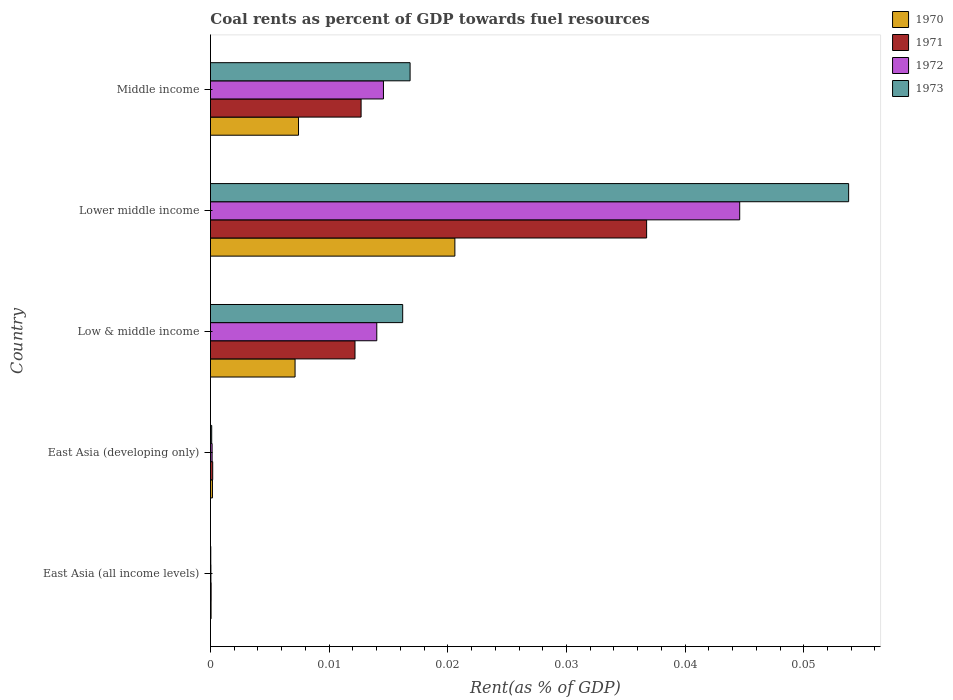How many different coloured bars are there?
Your answer should be compact. 4. How many groups of bars are there?
Offer a very short reply. 5. How many bars are there on the 3rd tick from the top?
Ensure brevity in your answer.  4. How many bars are there on the 3rd tick from the bottom?
Offer a very short reply. 4. What is the label of the 2nd group of bars from the top?
Give a very brief answer. Lower middle income. In how many cases, is the number of bars for a given country not equal to the number of legend labels?
Provide a short and direct response. 0. What is the coal rent in 1972 in Middle income?
Give a very brief answer. 0.01. Across all countries, what is the maximum coal rent in 1973?
Make the answer very short. 0.05. Across all countries, what is the minimum coal rent in 1972?
Offer a very short reply. 3.67730514806032e-5. In which country was the coal rent in 1970 maximum?
Give a very brief answer. Lower middle income. In which country was the coal rent in 1972 minimum?
Your answer should be compact. East Asia (all income levels). What is the total coal rent in 1970 in the graph?
Give a very brief answer. 0.04. What is the difference between the coal rent in 1970 in East Asia (all income levels) and that in Lower middle income?
Ensure brevity in your answer.  -0.02. What is the difference between the coal rent in 1973 in Middle income and the coal rent in 1972 in East Asia (all income levels)?
Your answer should be very brief. 0.02. What is the average coal rent in 1971 per country?
Provide a succinct answer. 0.01. What is the difference between the coal rent in 1973 and coal rent in 1971 in Low & middle income?
Your answer should be compact. 0. What is the ratio of the coal rent in 1971 in Lower middle income to that in Middle income?
Keep it short and to the point. 2.9. What is the difference between the highest and the second highest coal rent in 1971?
Provide a short and direct response. 0.02. What is the difference between the highest and the lowest coal rent in 1971?
Provide a short and direct response. 0.04. In how many countries, is the coal rent in 1970 greater than the average coal rent in 1970 taken over all countries?
Keep it short and to the point. 3. What does the 2nd bar from the bottom in Low & middle income represents?
Make the answer very short. 1971. Are all the bars in the graph horizontal?
Offer a very short reply. Yes. How many countries are there in the graph?
Provide a succinct answer. 5. Does the graph contain any zero values?
Offer a very short reply. No. Where does the legend appear in the graph?
Provide a short and direct response. Top right. How many legend labels are there?
Make the answer very short. 4. What is the title of the graph?
Your answer should be very brief. Coal rents as percent of GDP towards fuel resources. Does "1965" appear as one of the legend labels in the graph?
Ensure brevity in your answer.  No. What is the label or title of the X-axis?
Offer a terse response. Rent(as % of GDP). What is the label or title of the Y-axis?
Provide a short and direct response. Country. What is the Rent(as % of GDP) in 1970 in East Asia (all income levels)?
Provide a short and direct response. 5.1314079013758e-5. What is the Rent(as % of GDP) in 1971 in East Asia (all income levels)?
Ensure brevity in your answer.  5.470114168356261e-5. What is the Rent(as % of GDP) in 1972 in East Asia (all income levels)?
Offer a very short reply. 3.67730514806032e-5. What is the Rent(as % of GDP) of 1973 in East Asia (all income levels)?
Your answer should be very brief. 2.64171247686014e-5. What is the Rent(as % of GDP) in 1970 in East Asia (developing only)?
Give a very brief answer. 0. What is the Rent(as % of GDP) in 1971 in East Asia (developing only)?
Make the answer very short. 0. What is the Rent(as % of GDP) in 1972 in East Asia (developing only)?
Provide a short and direct response. 0. What is the Rent(as % of GDP) in 1973 in East Asia (developing only)?
Keep it short and to the point. 0. What is the Rent(as % of GDP) of 1970 in Low & middle income?
Keep it short and to the point. 0.01. What is the Rent(as % of GDP) in 1971 in Low & middle income?
Your answer should be compact. 0.01. What is the Rent(as % of GDP) of 1972 in Low & middle income?
Give a very brief answer. 0.01. What is the Rent(as % of GDP) in 1973 in Low & middle income?
Make the answer very short. 0.02. What is the Rent(as % of GDP) of 1970 in Lower middle income?
Your answer should be compact. 0.02. What is the Rent(as % of GDP) in 1971 in Lower middle income?
Make the answer very short. 0.04. What is the Rent(as % of GDP) in 1972 in Lower middle income?
Make the answer very short. 0.04. What is the Rent(as % of GDP) of 1973 in Lower middle income?
Keep it short and to the point. 0.05. What is the Rent(as % of GDP) in 1970 in Middle income?
Ensure brevity in your answer.  0.01. What is the Rent(as % of GDP) in 1971 in Middle income?
Your answer should be compact. 0.01. What is the Rent(as % of GDP) in 1972 in Middle income?
Your answer should be very brief. 0.01. What is the Rent(as % of GDP) in 1973 in Middle income?
Offer a very short reply. 0.02. Across all countries, what is the maximum Rent(as % of GDP) of 1970?
Ensure brevity in your answer.  0.02. Across all countries, what is the maximum Rent(as % of GDP) in 1971?
Provide a short and direct response. 0.04. Across all countries, what is the maximum Rent(as % of GDP) in 1972?
Ensure brevity in your answer.  0.04. Across all countries, what is the maximum Rent(as % of GDP) in 1973?
Your answer should be very brief. 0.05. Across all countries, what is the minimum Rent(as % of GDP) of 1970?
Offer a terse response. 5.1314079013758e-5. Across all countries, what is the minimum Rent(as % of GDP) in 1971?
Keep it short and to the point. 5.470114168356261e-5. Across all countries, what is the minimum Rent(as % of GDP) in 1972?
Your answer should be very brief. 3.67730514806032e-5. Across all countries, what is the minimum Rent(as % of GDP) in 1973?
Offer a terse response. 2.64171247686014e-5. What is the total Rent(as % of GDP) of 1970 in the graph?
Give a very brief answer. 0.04. What is the total Rent(as % of GDP) of 1971 in the graph?
Make the answer very short. 0.06. What is the total Rent(as % of GDP) in 1972 in the graph?
Offer a very short reply. 0.07. What is the total Rent(as % of GDP) in 1973 in the graph?
Make the answer very short. 0.09. What is the difference between the Rent(as % of GDP) of 1970 in East Asia (all income levels) and that in East Asia (developing only)?
Provide a short and direct response. -0. What is the difference between the Rent(as % of GDP) of 1971 in East Asia (all income levels) and that in East Asia (developing only)?
Offer a very short reply. -0. What is the difference between the Rent(as % of GDP) in 1972 in East Asia (all income levels) and that in East Asia (developing only)?
Offer a terse response. -0. What is the difference between the Rent(as % of GDP) in 1973 in East Asia (all income levels) and that in East Asia (developing only)?
Offer a very short reply. -0. What is the difference between the Rent(as % of GDP) in 1970 in East Asia (all income levels) and that in Low & middle income?
Make the answer very short. -0.01. What is the difference between the Rent(as % of GDP) in 1971 in East Asia (all income levels) and that in Low & middle income?
Your answer should be compact. -0.01. What is the difference between the Rent(as % of GDP) of 1972 in East Asia (all income levels) and that in Low & middle income?
Keep it short and to the point. -0.01. What is the difference between the Rent(as % of GDP) in 1973 in East Asia (all income levels) and that in Low & middle income?
Provide a short and direct response. -0.02. What is the difference between the Rent(as % of GDP) of 1970 in East Asia (all income levels) and that in Lower middle income?
Your response must be concise. -0.02. What is the difference between the Rent(as % of GDP) of 1971 in East Asia (all income levels) and that in Lower middle income?
Make the answer very short. -0.04. What is the difference between the Rent(as % of GDP) of 1972 in East Asia (all income levels) and that in Lower middle income?
Keep it short and to the point. -0.04. What is the difference between the Rent(as % of GDP) in 1973 in East Asia (all income levels) and that in Lower middle income?
Provide a succinct answer. -0.05. What is the difference between the Rent(as % of GDP) of 1970 in East Asia (all income levels) and that in Middle income?
Offer a terse response. -0.01. What is the difference between the Rent(as % of GDP) of 1971 in East Asia (all income levels) and that in Middle income?
Your answer should be very brief. -0.01. What is the difference between the Rent(as % of GDP) in 1972 in East Asia (all income levels) and that in Middle income?
Your response must be concise. -0.01. What is the difference between the Rent(as % of GDP) in 1973 in East Asia (all income levels) and that in Middle income?
Make the answer very short. -0.02. What is the difference between the Rent(as % of GDP) in 1970 in East Asia (developing only) and that in Low & middle income?
Offer a very short reply. -0.01. What is the difference between the Rent(as % of GDP) of 1971 in East Asia (developing only) and that in Low & middle income?
Ensure brevity in your answer.  -0.01. What is the difference between the Rent(as % of GDP) in 1972 in East Asia (developing only) and that in Low & middle income?
Make the answer very short. -0.01. What is the difference between the Rent(as % of GDP) of 1973 in East Asia (developing only) and that in Low & middle income?
Your response must be concise. -0.02. What is the difference between the Rent(as % of GDP) in 1970 in East Asia (developing only) and that in Lower middle income?
Offer a terse response. -0.02. What is the difference between the Rent(as % of GDP) of 1971 in East Asia (developing only) and that in Lower middle income?
Ensure brevity in your answer.  -0.04. What is the difference between the Rent(as % of GDP) in 1972 in East Asia (developing only) and that in Lower middle income?
Offer a very short reply. -0.04. What is the difference between the Rent(as % of GDP) in 1973 in East Asia (developing only) and that in Lower middle income?
Ensure brevity in your answer.  -0.05. What is the difference between the Rent(as % of GDP) of 1970 in East Asia (developing only) and that in Middle income?
Give a very brief answer. -0.01. What is the difference between the Rent(as % of GDP) of 1971 in East Asia (developing only) and that in Middle income?
Offer a terse response. -0.01. What is the difference between the Rent(as % of GDP) in 1972 in East Asia (developing only) and that in Middle income?
Provide a short and direct response. -0.01. What is the difference between the Rent(as % of GDP) in 1973 in East Asia (developing only) and that in Middle income?
Your answer should be very brief. -0.02. What is the difference between the Rent(as % of GDP) in 1970 in Low & middle income and that in Lower middle income?
Keep it short and to the point. -0.01. What is the difference between the Rent(as % of GDP) in 1971 in Low & middle income and that in Lower middle income?
Keep it short and to the point. -0.02. What is the difference between the Rent(as % of GDP) in 1972 in Low & middle income and that in Lower middle income?
Ensure brevity in your answer.  -0.03. What is the difference between the Rent(as % of GDP) of 1973 in Low & middle income and that in Lower middle income?
Give a very brief answer. -0.04. What is the difference between the Rent(as % of GDP) in 1970 in Low & middle income and that in Middle income?
Provide a short and direct response. -0. What is the difference between the Rent(as % of GDP) of 1971 in Low & middle income and that in Middle income?
Your answer should be compact. -0. What is the difference between the Rent(as % of GDP) in 1972 in Low & middle income and that in Middle income?
Your response must be concise. -0. What is the difference between the Rent(as % of GDP) in 1973 in Low & middle income and that in Middle income?
Give a very brief answer. -0. What is the difference between the Rent(as % of GDP) of 1970 in Lower middle income and that in Middle income?
Provide a short and direct response. 0.01. What is the difference between the Rent(as % of GDP) of 1971 in Lower middle income and that in Middle income?
Ensure brevity in your answer.  0.02. What is the difference between the Rent(as % of GDP) in 1973 in Lower middle income and that in Middle income?
Provide a succinct answer. 0.04. What is the difference between the Rent(as % of GDP) of 1970 in East Asia (all income levels) and the Rent(as % of GDP) of 1971 in East Asia (developing only)?
Your answer should be compact. -0. What is the difference between the Rent(as % of GDP) in 1970 in East Asia (all income levels) and the Rent(as % of GDP) in 1972 in East Asia (developing only)?
Your response must be concise. -0. What is the difference between the Rent(as % of GDP) in 1970 in East Asia (all income levels) and the Rent(as % of GDP) in 1973 in East Asia (developing only)?
Make the answer very short. -0. What is the difference between the Rent(as % of GDP) in 1971 in East Asia (all income levels) and the Rent(as % of GDP) in 1972 in East Asia (developing only)?
Provide a short and direct response. -0. What is the difference between the Rent(as % of GDP) in 1972 in East Asia (all income levels) and the Rent(as % of GDP) in 1973 in East Asia (developing only)?
Offer a very short reply. -0. What is the difference between the Rent(as % of GDP) of 1970 in East Asia (all income levels) and the Rent(as % of GDP) of 1971 in Low & middle income?
Give a very brief answer. -0.01. What is the difference between the Rent(as % of GDP) in 1970 in East Asia (all income levels) and the Rent(as % of GDP) in 1972 in Low & middle income?
Ensure brevity in your answer.  -0.01. What is the difference between the Rent(as % of GDP) of 1970 in East Asia (all income levels) and the Rent(as % of GDP) of 1973 in Low & middle income?
Make the answer very short. -0.02. What is the difference between the Rent(as % of GDP) of 1971 in East Asia (all income levels) and the Rent(as % of GDP) of 1972 in Low & middle income?
Your answer should be compact. -0.01. What is the difference between the Rent(as % of GDP) of 1971 in East Asia (all income levels) and the Rent(as % of GDP) of 1973 in Low & middle income?
Your response must be concise. -0.02. What is the difference between the Rent(as % of GDP) of 1972 in East Asia (all income levels) and the Rent(as % of GDP) of 1973 in Low & middle income?
Keep it short and to the point. -0.02. What is the difference between the Rent(as % of GDP) in 1970 in East Asia (all income levels) and the Rent(as % of GDP) in 1971 in Lower middle income?
Ensure brevity in your answer.  -0.04. What is the difference between the Rent(as % of GDP) in 1970 in East Asia (all income levels) and the Rent(as % of GDP) in 1972 in Lower middle income?
Offer a very short reply. -0.04. What is the difference between the Rent(as % of GDP) of 1970 in East Asia (all income levels) and the Rent(as % of GDP) of 1973 in Lower middle income?
Your response must be concise. -0.05. What is the difference between the Rent(as % of GDP) in 1971 in East Asia (all income levels) and the Rent(as % of GDP) in 1972 in Lower middle income?
Offer a very short reply. -0.04. What is the difference between the Rent(as % of GDP) of 1971 in East Asia (all income levels) and the Rent(as % of GDP) of 1973 in Lower middle income?
Provide a short and direct response. -0.05. What is the difference between the Rent(as % of GDP) in 1972 in East Asia (all income levels) and the Rent(as % of GDP) in 1973 in Lower middle income?
Your answer should be compact. -0.05. What is the difference between the Rent(as % of GDP) of 1970 in East Asia (all income levels) and the Rent(as % of GDP) of 1971 in Middle income?
Your answer should be compact. -0.01. What is the difference between the Rent(as % of GDP) in 1970 in East Asia (all income levels) and the Rent(as % of GDP) in 1972 in Middle income?
Provide a succinct answer. -0.01. What is the difference between the Rent(as % of GDP) in 1970 in East Asia (all income levels) and the Rent(as % of GDP) in 1973 in Middle income?
Offer a terse response. -0.02. What is the difference between the Rent(as % of GDP) of 1971 in East Asia (all income levels) and the Rent(as % of GDP) of 1972 in Middle income?
Ensure brevity in your answer.  -0.01. What is the difference between the Rent(as % of GDP) of 1971 in East Asia (all income levels) and the Rent(as % of GDP) of 1973 in Middle income?
Keep it short and to the point. -0.02. What is the difference between the Rent(as % of GDP) in 1972 in East Asia (all income levels) and the Rent(as % of GDP) in 1973 in Middle income?
Provide a succinct answer. -0.02. What is the difference between the Rent(as % of GDP) of 1970 in East Asia (developing only) and the Rent(as % of GDP) of 1971 in Low & middle income?
Provide a short and direct response. -0.01. What is the difference between the Rent(as % of GDP) in 1970 in East Asia (developing only) and the Rent(as % of GDP) in 1972 in Low & middle income?
Offer a terse response. -0.01. What is the difference between the Rent(as % of GDP) of 1970 in East Asia (developing only) and the Rent(as % of GDP) of 1973 in Low & middle income?
Offer a terse response. -0.02. What is the difference between the Rent(as % of GDP) of 1971 in East Asia (developing only) and the Rent(as % of GDP) of 1972 in Low & middle income?
Your answer should be very brief. -0.01. What is the difference between the Rent(as % of GDP) of 1971 in East Asia (developing only) and the Rent(as % of GDP) of 1973 in Low & middle income?
Give a very brief answer. -0.02. What is the difference between the Rent(as % of GDP) of 1972 in East Asia (developing only) and the Rent(as % of GDP) of 1973 in Low & middle income?
Keep it short and to the point. -0.02. What is the difference between the Rent(as % of GDP) in 1970 in East Asia (developing only) and the Rent(as % of GDP) in 1971 in Lower middle income?
Make the answer very short. -0.04. What is the difference between the Rent(as % of GDP) in 1970 in East Asia (developing only) and the Rent(as % of GDP) in 1972 in Lower middle income?
Give a very brief answer. -0.04. What is the difference between the Rent(as % of GDP) in 1970 in East Asia (developing only) and the Rent(as % of GDP) in 1973 in Lower middle income?
Ensure brevity in your answer.  -0.05. What is the difference between the Rent(as % of GDP) of 1971 in East Asia (developing only) and the Rent(as % of GDP) of 1972 in Lower middle income?
Your response must be concise. -0.04. What is the difference between the Rent(as % of GDP) in 1971 in East Asia (developing only) and the Rent(as % of GDP) in 1973 in Lower middle income?
Offer a very short reply. -0.05. What is the difference between the Rent(as % of GDP) in 1972 in East Asia (developing only) and the Rent(as % of GDP) in 1973 in Lower middle income?
Your response must be concise. -0.05. What is the difference between the Rent(as % of GDP) in 1970 in East Asia (developing only) and the Rent(as % of GDP) in 1971 in Middle income?
Keep it short and to the point. -0.01. What is the difference between the Rent(as % of GDP) of 1970 in East Asia (developing only) and the Rent(as % of GDP) of 1972 in Middle income?
Your answer should be compact. -0.01. What is the difference between the Rent(as % of GDP) of 1970 in East Asia (developing only) and the Rent(as % of GDP) of 1973 in Middle income?
Offer a terse response. -0.02. What is the difference between the Rent(as % of GDP) in 1971 in East Asia (developing only) and the Rent(as % of GDP) in 1972 in Middle income?
Your answer should be compact. -0.01. What is the difference between the Rent(as % of GDP) of 1971 in East Asia (developing only) and the Rent(as % of GDP) of 1973 in Middle income?
Your answer should be very brief. -0.02. What is the difference between the Rent(as % of GDP) in 1972 in East Asia (developing only) and the Rent(as % of GDP) in 1973 in Middle income?
Ensure brevity in your answer.  -0.02. What is the difference between the Rent(as % of GDP) of 1970 in Low & middle income and the Rent(as % of GDP) of 1971 in Lower middle income?
Provide a succinct answer. -0.03. What is the difference between the Rent(as % of GDP) of 1970 in Low & middle income and the Rent(as % of GDP) of 1972 in Lower middle income?
Ensure brevity in your answer.  -0.04. What is the difference between the Rent(as % of GDP) in 1970 in Low & middle income and the Rent(as % of GDP) in 1973 in Lower middle income?
Offer a terse response. -0.05. What is the difference between the Rent(as % of GDP) in 1971 in Low & middle income and the Rent(as % of GDP) in 1972 in Lower middle income?
Ensure brevity in your answer.  -0.03. What is the difference between the Rent(as % of GDP) in 1971 in Low & middle income and the Rent(as % of GDP) in 1973 in Lower middle income?
Make the answer very short. -0.04. What is the difference between the Rent(as % of GDP) of 1972 in Low & middle income and the Rent(as % of GDP) of 1973 in Lower middle income?
Provide a succinct answer. -0.04. What is the difference between the Rent(as % of GDP) of 1970 in Low & middle income and the Rent(as % of GDP) of 1971 in Middle income?
Give a very brief answer. -0.01. What is the difference between the Rent(as % of GDP) in 1970 in Low & middle income and the Rent(as % of GDP) in 1972 in Middle income?
Offer a terse response. -0.01. What is the difference between the Rent(as % of GDP) of 1970 in Low & middle income and the Rent(as % of GDP) of 1973 in Middle income?
Keep it short and to the point. -0.01. What is the difference between the Rent(as % of GDP) in 1971 in Low & middle income and the Rent(as % of GDP) in 1972 in Middle income?
Offer a terse response. -0. What is the difference between the Rent(as % of GDP) of 1971 in Low & middle income and the Rent(as % of GDP) of 1973 in Middle income?
Provide a short and direct response. -0. What is the difference between the Rent(as % of GDP) of 1972 in Low & middle income and the Rent(as % of GDP) of 1973 in Middle income?
Ensure brevity in your answer.  -0. What is the difference between the Rent(as % of GDP) in 1970 in Lower middle income and the Rent(as % of GDP) in 1971 in Middle income?
Your response must be concise. 0.01. What is the difference between the Rent(as % of GDP) in 1970 in Lower middle income and the Rent(as % of GDP) in 1972 in Middle income?
Offer a very short reply. 0.01. What is the difference between the Rent(as % of GDP) of 1970 in Lower middle income and the Rent(as % of GDP) of 1973 in Middle income?
Provide a short and direct response. 0. What is the difference between the Rent(as % of GDP) of 1971 in Lower middle income and the Rent(as % of GDP) of 1972 in Middle income?
Your answer should be very brief. 0.02. What is the difference between the Rent(as % of GDP) of 1971 in Lower middle income and the Rent(as % of GDP) of 1973 in Middle income?
Your response must be concise. 0.02. What is the difference between the Rent(as % of GDP) in 1972 in Lower middle income and the Rent(as % of GDP) in 1973 in Middle income?
Offer a terse response. 0.03. What is the average Rent(as % of GDP) of 1970 per country?
Keep it short and to the point. 0.01. What is the average Rent(as % of GDP) of 1971 per country?
Provide a succinct answer. 0.01. What is the average Rent(as % of GDP) in 1972 per country?
Provide a short and direct response. 0.01. What is the average Rent(as % of GDP) of 1973 per country?
Provide a short and direct response. 0.02. What is the difference between the Rent(as % of GDP) in 1970 and Rent(as % of GDP) in 1971 in East Asia (all income levels)?
Make the answer very short. -0. What is the difference between the Rent(as % of GDP) of 1970 and Rent(as % of GDP) of 1973 in East Asia (all income levels)?
Offer a terse response. 0. What is the difference between the Rent(as % of GDP) in 1971 and Rent(as % of GDP) in 1973 in East Asia (all income levels)?
Offer a terse response. 0. What is the difference between the Rent(as % of GDP) in 1972 and Rent(as % of GDP) in 1973 in East Asia (all income levels)?
Offer a very short reply. 0. What is the difference between the Rent(as % of GDP) in 1970 and Rent(as % of GDP) in 1972 in East Asia (developing only)?
Your answer should be very brief. 0. What is the difference between the Rent(as % of GDP) of 1971 and Rent(as % of GDP) of 1973 in East Asia (developing only)?
Offer a very short reply. 0. What is the difference between the Rent(as % of GDP) of 1972 and Rent(as % of GDP) of 1973 in East Asia (developing only)?
Keep it short and to the point. 0. What is the difference between the Rent(as % of GDP) of 1970 and Rent(as % of GDP) of 1971 in Low & middle income?
Ensure brevity in your answer.  -0.01. What is the difference between the Rent(as % of GDP) in 1970 and Rent(as % of GDP) in 1972 in Low & middle income?
Provide a succinct answer. -0.01. What is the difference between the Rent(as % of GDP) in 1970 and Rent(as % of GDP) in 1973 in Low & middle income?
Give a very brief answer. -0.01. What is the difference between the Rent(as % of GDP) of 1971 and Rent(as % of GDP) of 1972 in Low & middle income?
Ensure brevity in your answer.  -0. What is the difference between the Rent(as % of GDP) of 1971 and Rent(as % of GDP) of 1973 in Low & middle income?
Your answer should be very brief. -0. What is the difference between the Rent(as % of GDP) in 1972 and Rent(as % of GDP) in 1973 in Low & middle income?
Provide a short and direct response. -0. What is the difference between the Rent(as % of GDP) of 1970 and Rent(as % of GDP) of 1971 in Lower middle income?
Your answer should be very brief. -0.02. What is the difference between the Rent(as % of GDP) in 1970 and Rent(as % of GDP) in 1972 in Lower middle income?
Offer a terse response. -0.02. What is the difference between the Rent(as % of GDP) in 1970 and Rent(as % of GDP) in 1973 in Lower middle income?
Give a very brief answer. -0.03. What is the difference between the Rent(as % of GDP) in 1971 and Rent(as % of GDP) in 1972 in Lower middle income?
Provide a short and direct response. -0.01. What is the difference between the Rent(as % of GDP) of 1971 and Rent(as % of GDP) of 1973 in Lower middle income?
Keep it short and to the point. -0.02. What is the difference between the Rent(as % of GDP) in 1972 and Rent(as % of GDP) in 1973 in Lower middle income?
Keep it short and to the point. -0.01. What is the difference between the Rent(as % of GDP) of 1970 and Rent(as % of GDP) of 1971 in Middle income?
Ensure brevity in your answer.  -0.01. What is the difference between the Rent(as % of GDP) of 1970 and Rent(as % of GDP) of 1972 in Middle income?
Your answer should be compact. -0.01. What is the difference between the Rent(as % of GDP) of 1970 and Rent(as % of GDP) of 1973 in Middle income?
Offer a very short reply. -0.01. What is the difference between the Rent(as % of GDP) of 1971 and Rent(as % of GDP) of 1972 in Middle income?
Make the answer very short. -0. What is the difference between the Rent(as % of GDP) of 1971 and Rent(as % of GDP) of 1973 in Middle income?
Your response must be concise. -0. What is the difference between the Rent(as % of GDP) in 1972 and Rent(as % of GDP) in 1973 in Middle income?
Your answer should be very brief. -0. What is the ratio of the Rent(as % of GDP) of 1970 in East Asia (all income levels) to that in East Asia (developing only)?
Your response must be concise. 0.31. What is the ratio of the Rent(as % of GDP) in 1971 in East Asia (all income levels) to that in East Asia (developing only)?
Give a very brief answer. 0.29. What is the ratio of the Rent(as % of GDP) in 1972 in East Asia (all income levels) to that in East Asia (developing only)?
Offer a terse response. 0.27. What is the ratio of the Rent(as % of GDP) of 1973 in East Asia (all income levels) to that in East Asia (developing only)?
Offer a terse response. 0.26. What is the ratio of the Rent(as % of GDP) of 1970 in East Asia (all income levels) to that in Low & middle income?
Give a very brief answer. 0.01. What is the ratio of the Rent(as % of GDP) in 1971 in East Asia (all income levels) to that in Low & middle income?
Your answer should be compact. 0. What is the ratio of the Rent(as % of GDP) in 1972 in East Asia (all income levels) to that in Low & middle income?
Make the answer very short. 0. What is the ratio of the Rent(as % of GDP) in 1973 in East Asia (all income levels) to that in Low & middle income?
Make the answer very short. 0. What is the ratio of the Rent(as % of GDP) in 1970 in East Asia (all income levels) to that in Lower middle income?
Keep it short and to the point. 0. What is the ratio of the Rent(as % of GDP) in 1971 in East Asia (all income levels) to that in Lower middle income?
Your answer should be very brief. 0. What is the ratio of the Rent(as % of GDP) of 1972 in East Asia (all income levels) to that in Lower middle income?
Give a very brief answer. 0. What is the ratio of the Rent(as % of GDP) of 1973 in East Asia (all income levels) to that in Lower middle income?
Offer a terse response. 0. What is the ratio of the Rent(as % of GDP) of 1970 in East Asia (all income levels) to that in Middle income?
Your answer should be very brief. 0.01. What is the ratio of the Rent(as % of GDP) of 1971 in East Asia (all income levels) to that in Middle income?
Your response must be concise. 0. What is the ratio of the Rent(as % of GDP) of 1972 in East Asia (all income levels) to that in Middle income?
Ensure brevity in your answer.  0. What is the ratio of the Rent(as % of GDP) of 1973 in East Asia (all income levels) to that in Middle income?
Offer a very short reply. 0. What is the ratio of the Rent(as % of GDP) of 1970 in East Asia (developing only) to that in Low & middle income?
Provide a succinct answer. 0.02. What is the ratio of the Rent(as % of GDP) of 1971 in East Asia (developing only) to that in Low & middle income?
Offer a very short reply. 0.02. What is the ratio of the Rent(as % of GDP) of 1972 in East Asia (developing only) to that in Low & middle income?
Provide a succinct answer. 0.01. What is the ratio of the Rent(as % of GDP) of 1973 in East Asia (developing only) to that in Low & middle income?
Provide a succinct answer. 0.01. What is the ratio of the Rent(as % of GDP) of 1970 in East Asia (developing only) to that in Lower middle income?
Provide a short and direct response. 0.01. What is the ratio of the Rent(as % of GDP) of 1971 in East Asia (developing only) to that in Lower middle income?
Ensure brevity in your answer.  0.01. What is the ratio of the Rent(as % of GDP) of 1972 in East Asia (developing only) to that in Lower middle income?
Your answer should be very brief. 0. What is the ratio of the Rent(as % of GDP) in 1973 in East Asia (developing only) to that in Lower middle income?
Your answer should be very brief. 0. What is the ratio of the Rent(as % of GDP) in 1970 in East Asia (developing only) to that in Middle income?
Provide a short and direct response. 0.02. What is the ratio of the Rent(as % of GDP) in 1971 in East Asia (developing only) to that in Middle income?
Provide a short and direct response. 0.01. What is the ratio of the Rent(as % of GDP) in 1972 in East Asia (developing only) to that in Middle income?
Make the answer very short. 0.01. What is the ratio of the Rent(as % of GDP) in 1973 in East Asia (developing only) to that in Middle income?
Provide a short and direct response. 0.01. What is the ratio of the Rent(as % of GDP) of 1970 in Low & middle income to that in Lower middle income?
Offer a terse response. 0.35. What is the ratio of the Rent(as % of GDP) in 1971 in Low & middle income to that in Lower middle income?
Keep it short and to the point. 0.33. What is the ratio of the Rent(as % of GDP) in 1972 in Low & middle income to that in Lower middle income?
Offer a terse response. 0.31. What is the ratio of the Rent(as % of GDP) of 1973 in Low & middle income to that in Lower middle income?
Make the answer very short. 0.3. What is the ratio of the Rent(as % of GDP) in 1970 in Low & middle income to that in Middle income?
Offer a terse response. 0.96. What is the ratio of the Rent(as % of GDP) in 1971 in Low & middle income to that in Middle income?
Your answer should be compact. 0.96. What is the ratio of the Rent(as % of GDP) in 1972 in Low & middle income to that in Middle income?
Your answer should be compact. 0.96. What is the ratio of the Rent(as % of GDP) of 1973 in Low & middle income to that in Middle income?
Give a very brief answer. 0.96. What is the ratio of the Rent(as % of GDP) in 1970 in Lower middle income to that in Middle income?
Your answer should be compact. 2.78. What is the ratio of the Rent(as % of GDP) in 1971 in Lower middle income to that in Middle income?
Provide a succinct answer. 2.9. What is the ratio of the Rent(as % of GDP) in 1972 in Lower middle income to that in Middle income?
Your answer should be very brief. 3.06. What is the ratio of the Rent(as % of GDP) of 1973 in Lower middle income to that in Middle income?
Keep it short and to the point. 3.2. What is the difference between the highest and the second highest Rent(as % of GDP) in 1970?
Give a very brief answer. 0.01. What is the difference between the highest and the second highest Rent(as % of GDP) of 1971?
Provide a short and direct response. 0.02. What is the difference between the highest and the second highest Rent(as % of GDP) in 1972?
Your answer should be compact. 0.03. What is the difference between the highest and the second highest Rent(as % of GDP) in 1973?
Ensure brevity in your answer.  0.04. What is the difference between the highest and the lowest Rent(as % of GDP) of 1970?
Offer a terse response. 0.02. What is the difference between the highest and the lowest Rent(as % of GDP) in 1971?
Give a very brief answer. 0.04. What is the difference between the highest and the lowest Rent(as % of GDP) of 1972?
Make the answer very short. 0.04. What is the difference between the highest and the lowest Rent(as % of GDP) of 1973?
Offer a terse response. 0.05. 